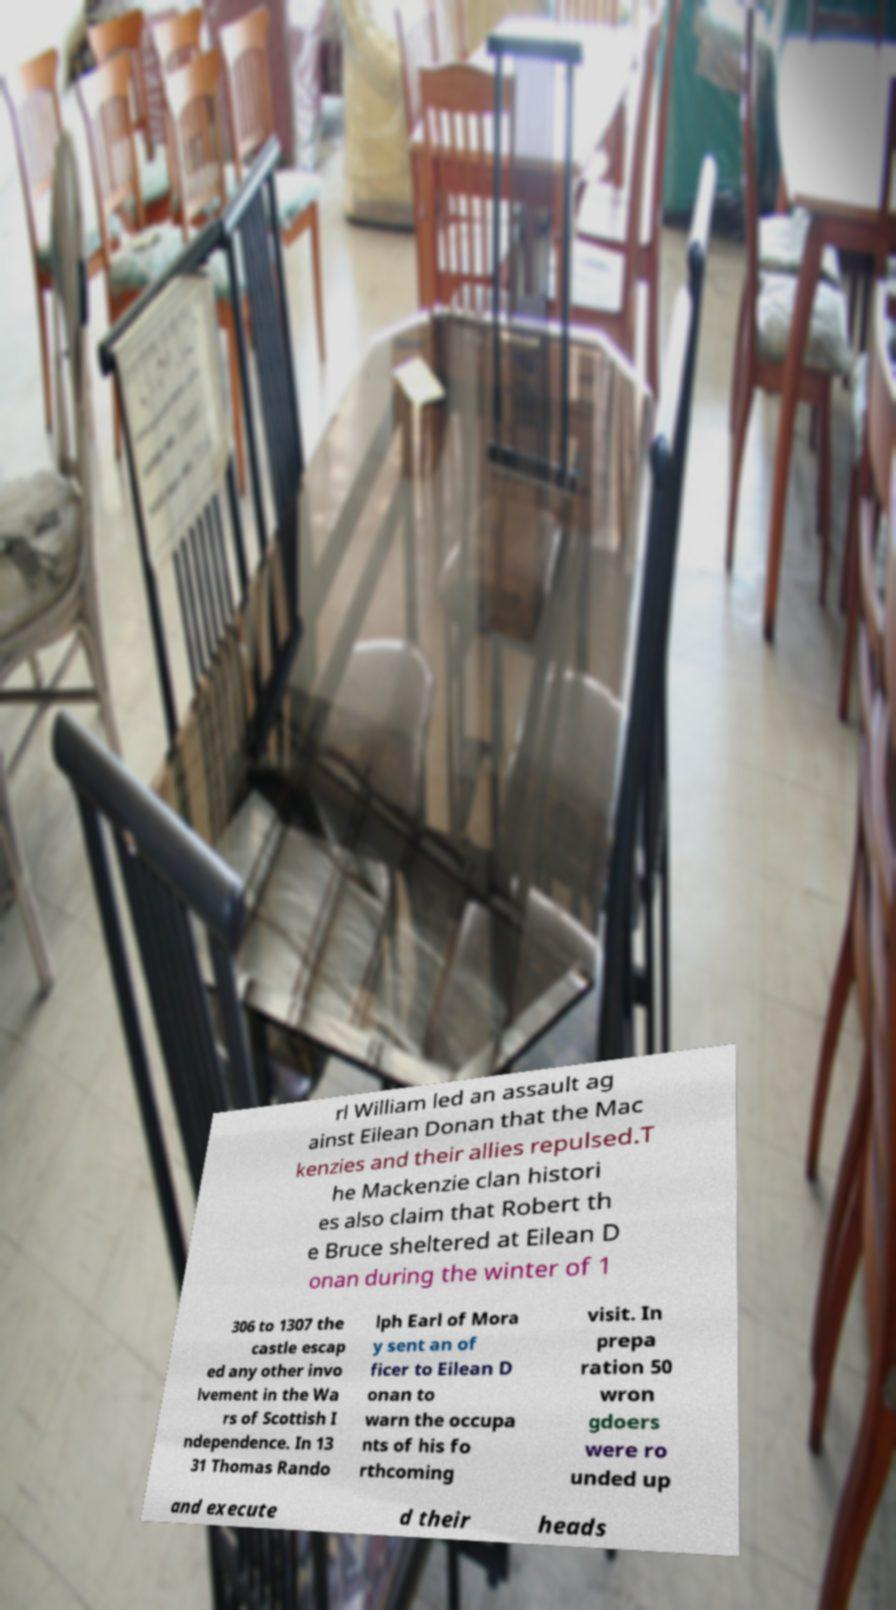I need the written content from this picture converted into text. Can you do that? rl William led an assault ag ainst Eilean Donan that the Mac kenzies and their allies repulsed.T he Mackenzie clan histori es also claim that Robert th e Bruce sheltered at Eilean D onan during the winter of 1 306 to 1307 the castle escap ed any other invo lvement in the Wa rs of Scottish I ndependence. In 13 31 Thomas Rando lph Earl of Mora y sent an of ficer to Eilean D onan to warn the occupa nts of his fo rthcoming visit. In prepa ration 50 wron gdoers were ro unded up and execute d their heads 